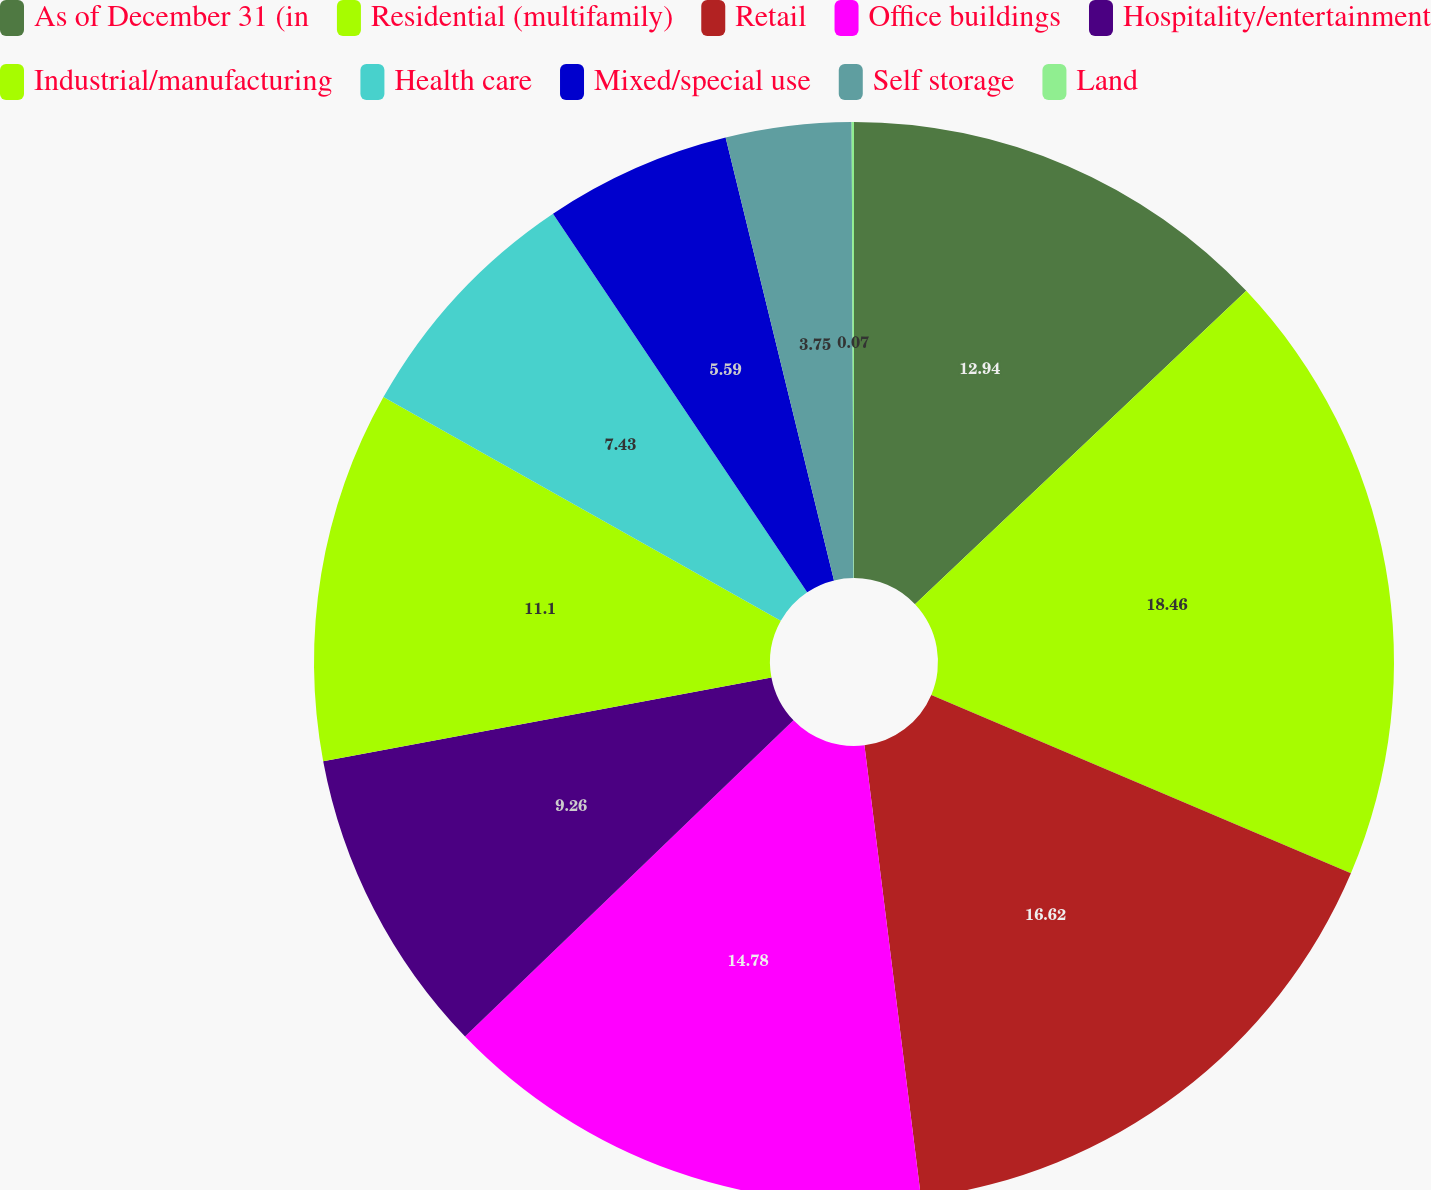Convert chart. <chart><loc_0><loc_0><loc_500><loc_500><pie_chart><fcel>As of December 31 (in<fcel>Residential (multifamily)<fcel>Retail<fcel>Office buildings<fcel>Hospitality/entertainment<fcel>Industrial/manufacturing<fcel>Health care<fcel>Mixed/special use<fcel>Self storage<fcel>Land<nl><fcel>12.94%<fcel>18.46%<fcel>16.62%<fcel>14.78%<fcel>9.26%<fcel>11.1%<fcel>7.43%<fcel>5.59%<fcel>3.75%<fcel>0.07%<nl></chart> 